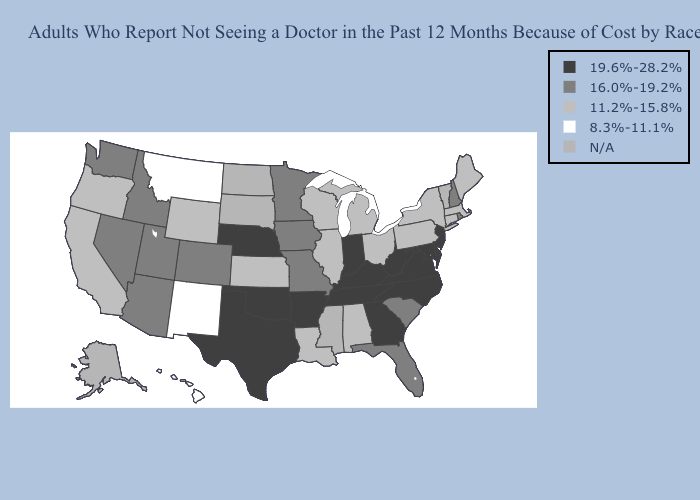What is the value of Arizona?
Keep it brief. 16.0%-19.2%. Among the states that border Pennsylvania , does Ohio have the highest value?
Keep it brief. No. Among the states that border Arkansas , does Texas have the highest value?
Quick response, please. Yes. What is the lowest value in states that border Montana?
Short answer required. 11.2%-15.8%. Does Nebraska have the lowest value in the MidWest?
Short answer required. No. Which states have the lowest value in the USA?
Answer briefly. Hawaii, Montana, New Mexico. Name the states that have a value in the range 16.0%-19.2%?
Write a very short answer. Arizona, Colorado, Florida, Idaho, Iowa, Minnesota, Missouri, Nevada, New Hampshire, Rhode Island, South Carolina, Utah, Washington. What is the value of New Hampshire?
Answer briefly. 16.0%-19.2%. What is the highest value in states that border Florida?
Concise answer only. 19.6%-28.2%. Name the states that have a value in the range 19.6%-28.2%?
Give a very brief answer. Arkansas, Delaware, Georgia, Indiana, Kentucky, Maryland, Nebraska, New Jersey, North Carolina, Oklahoma, Tennessee, Texas, Virginia, West Virginia. Does the map have missing data?
Concise answer only. Yes. What is the highest value in the West ?
Answer briefly. 16.0%-19.2%. Does Utah have the lowest value in the West?
Keep it brief. No. 